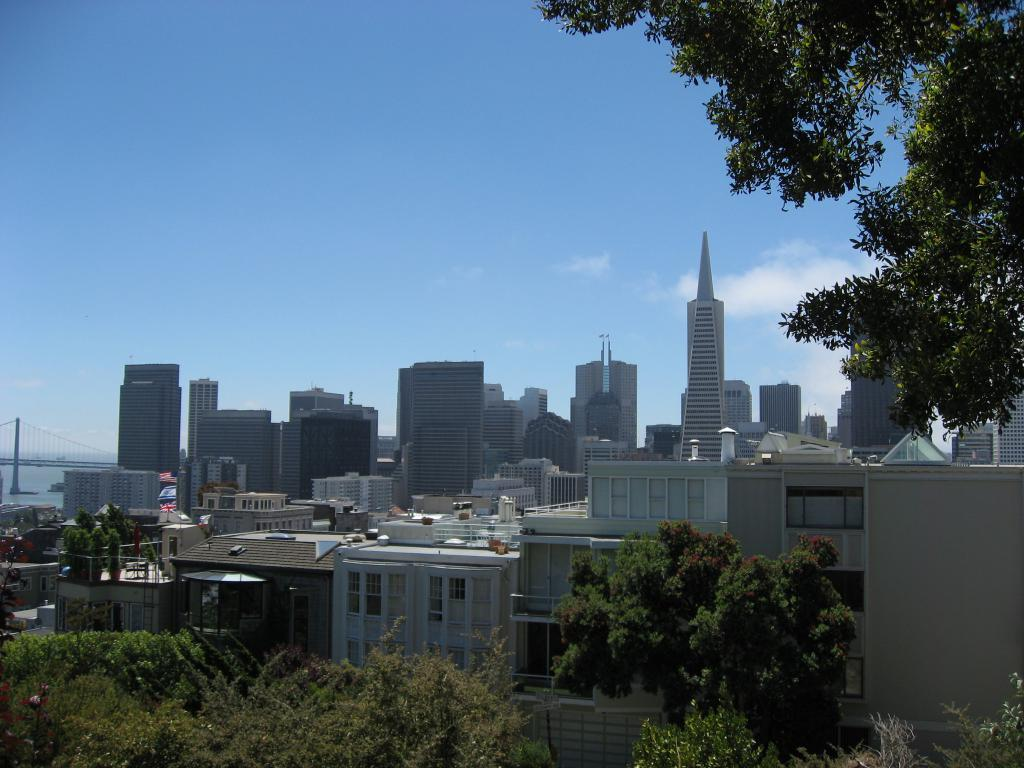Where was the image taken? The image was clicked outside. What can be seen in the middle of the image? There are buildings in the middle of the image. What type of vegetation is present at the bottom and right side of the image? There are trees at the bottom and right side of the image. What is visible at the top of the image? The sky is visible at the top of the image. How many oranges are hanging from the trees in the image? There are no oranges present in the image; it features trees without any fruit. What type of market is visible in the image? There is no market present in the image; it features buildings, trees, and the sky. 